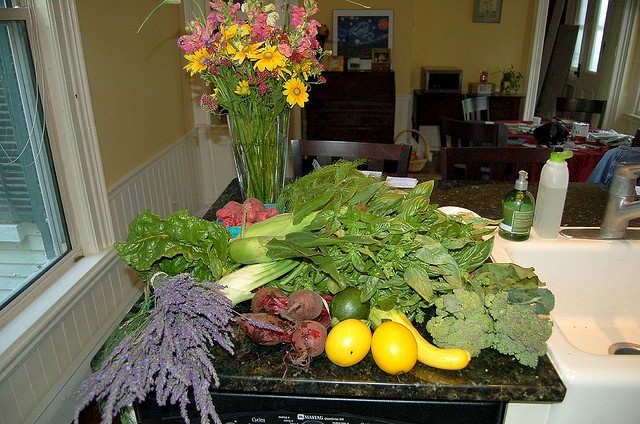Describe the objects in this image and their specific colors. I can see sink in black, tan, beige, gray, and darkgreen tones, broccoli in black, olive, and tan tones, vase in black, darkgreen, and gray tones, chair in black, maroon, darkgreen, and tan tones, and chair in black, gray, and darkgreen tones in this image. 